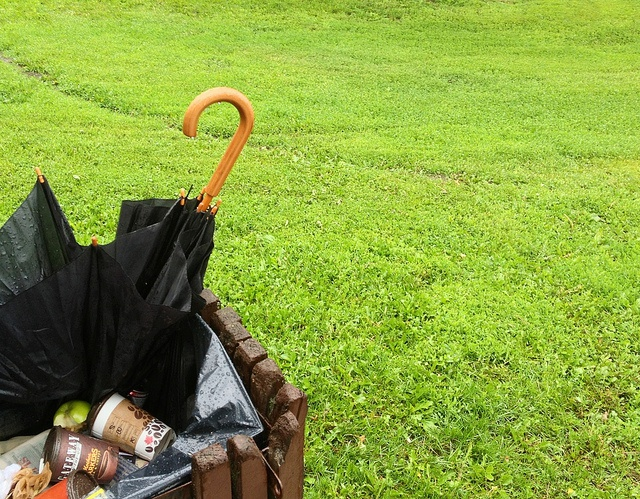Describe the objects in this image and their specific colors. I can see umbrella in yellow, black, and gray tones, umbrella in yellow, black, orange, and khaki tones, cup in yellow, lightgray, black, and tan tones, cup in yellow, gray, maroon, and black tones, and apple in yellow, olive, black, and tan tones in this image. 